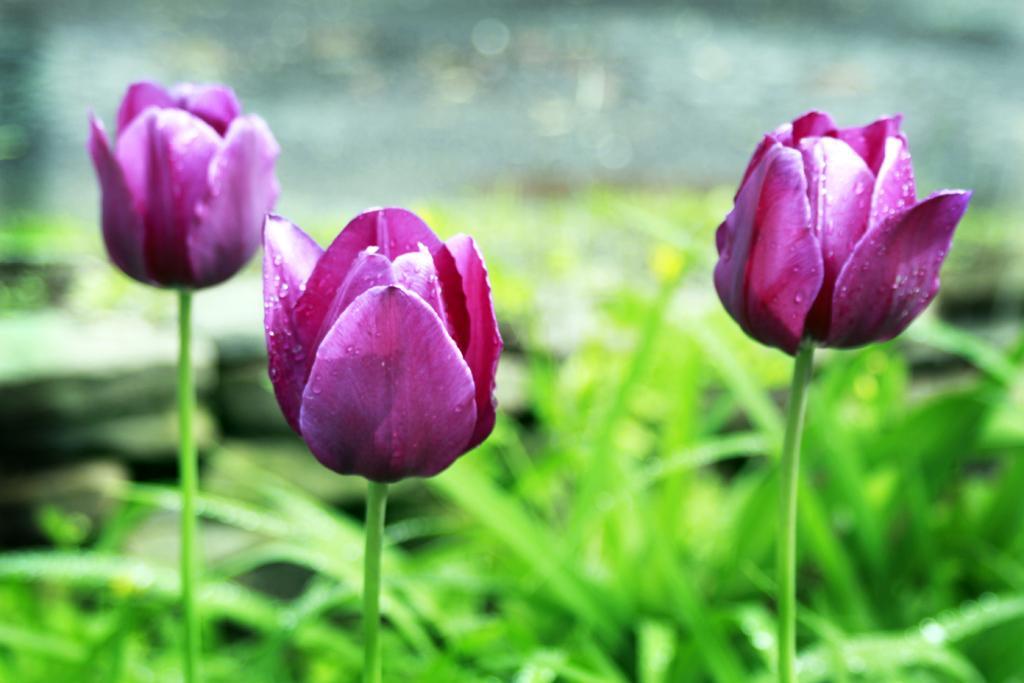In one or two sentences, can you explain what this image depicts? This is a tulip flower. Its is purple in colour and we can see few droplets of water on the flower. On the background of the picture we cannot see anything because it's very blur. 